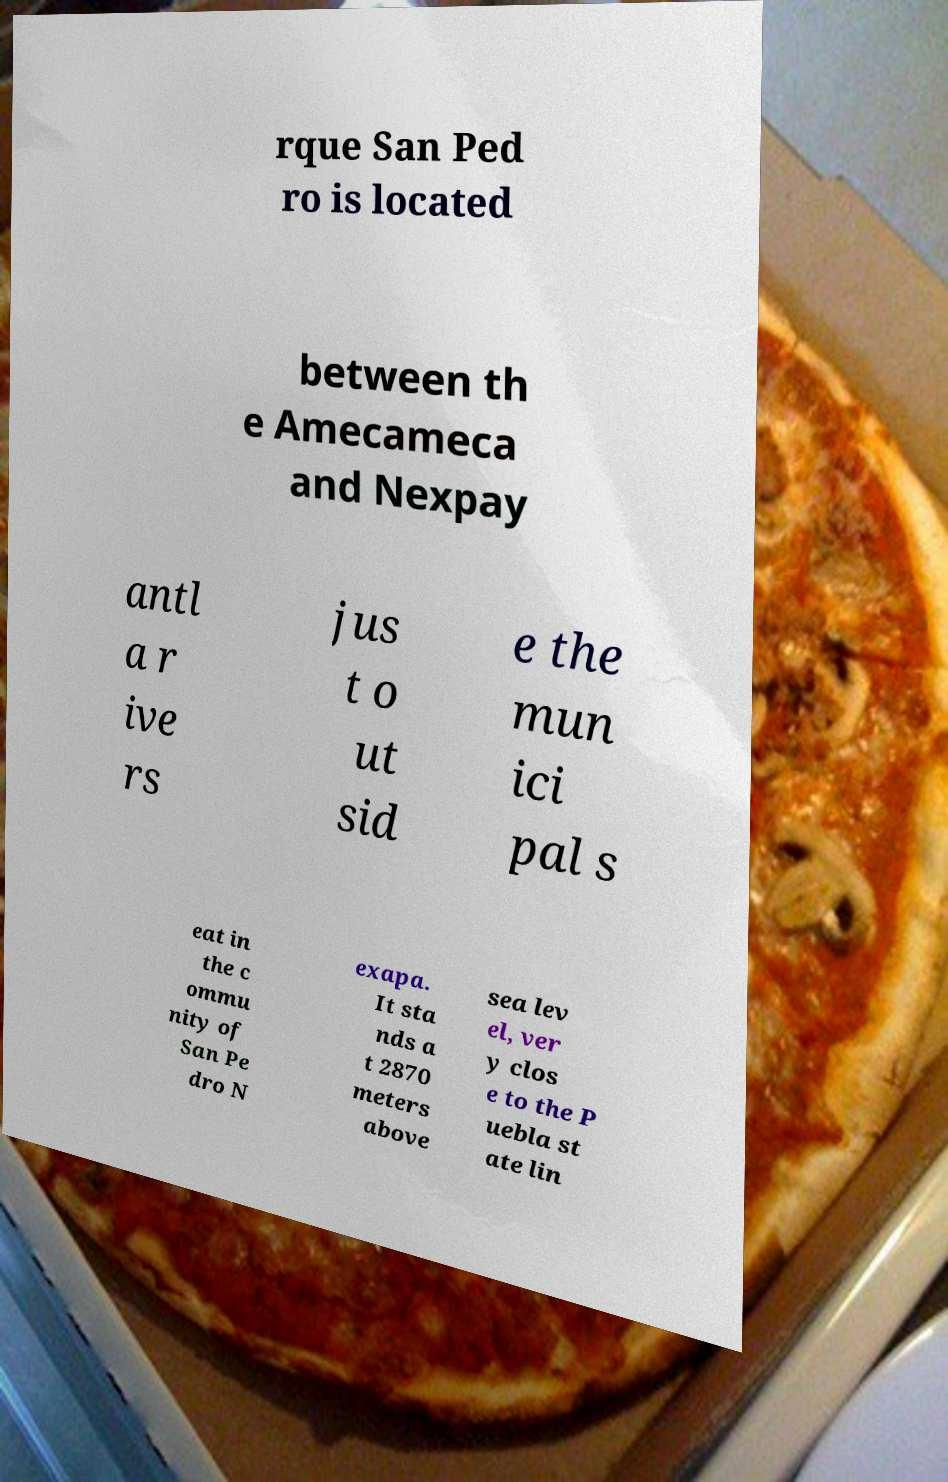For documentation purposes, I need the text within this image transcribed. Could you provide that? rque San Ped ro is located between th e Amecameca and Nexpay antl a r ive rs jus t o ut sid e the mun ici pal s eat in the c ommu nity of San Pe dro N exapa. It sta nds a t 2870 meters above sea lev el, ver y clos e to the P uebla st ate lin 